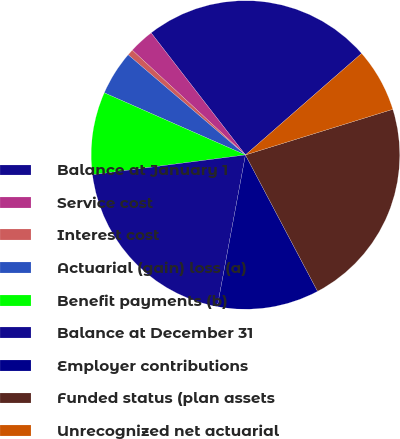<chart> <loc_0><loc_0><loc_500><loc_500><pie_chart><fcel>Balance at January 1<fcel>Service cost<fcel>Interest cost<fcel>Actuarial (gain) loss (a)<fcel>Benefit payments (b)<fcel>Balance at December 31<fcel>Employer contributions<fcel>Funded status (plan assets<fcel>Unrecognized net actuarial<nl><fcel>24.04%<fcel>2.64%<fcel>0.64%<fcel>4.65%<fcel>8.65%<fcel>20.03%<fcel>10.66%<fcel>22.04%<fcel>6.65%<nl></chart> 